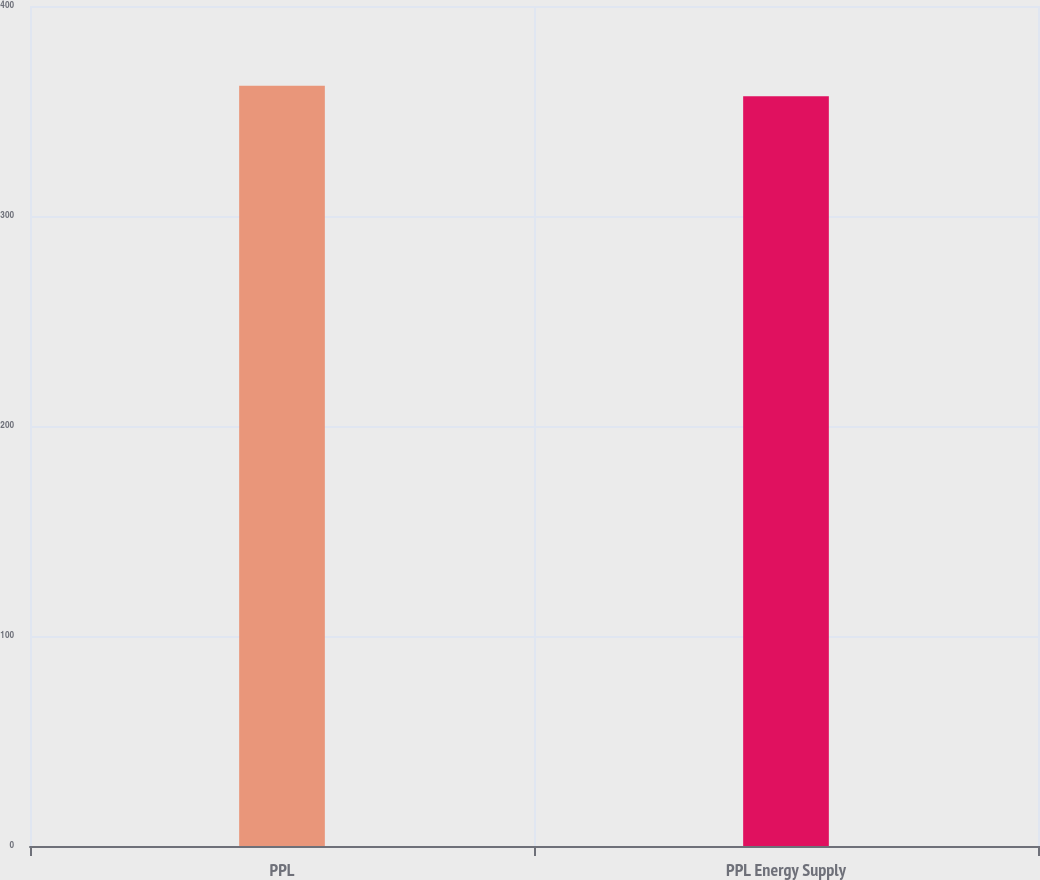Convert chart. <chart><loc_0><loc_0><loc_500><loc_500><bar_chart><fcel>PPL<fcel>PPL Energy Supply<nl><fcel>362<fcel>357<nl></chart> 